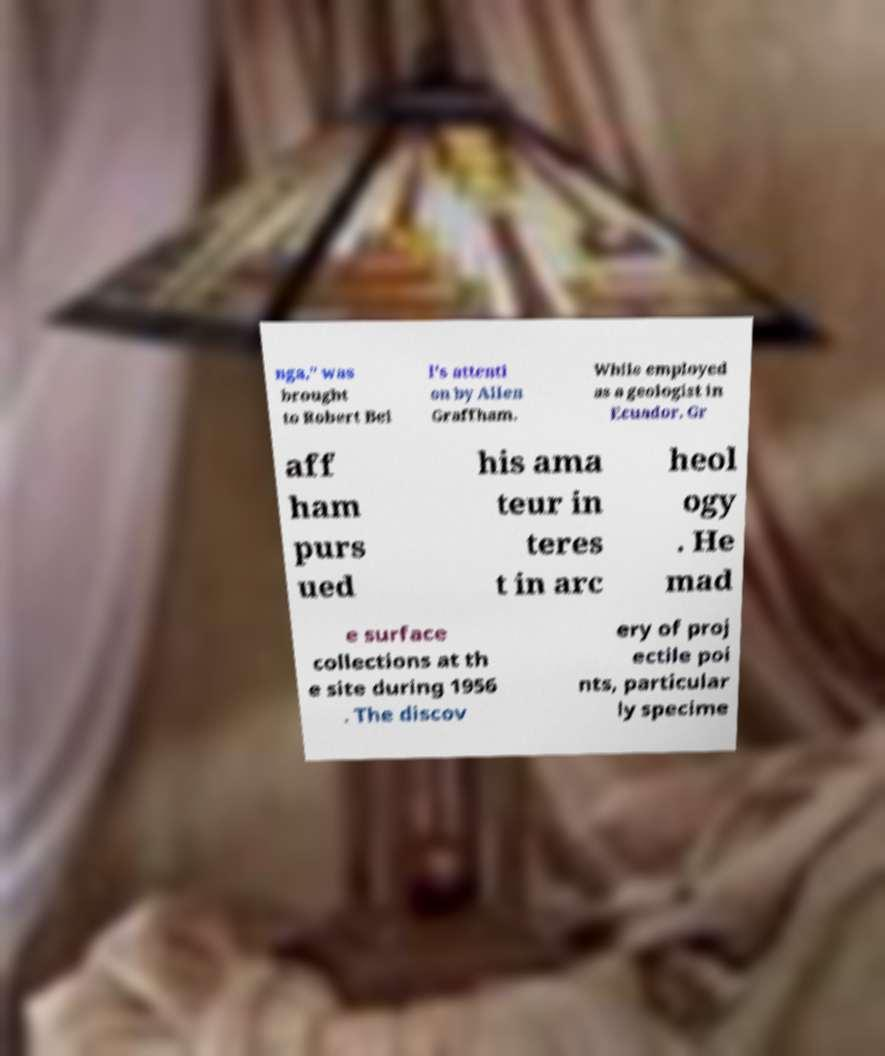Could you extract and type out the text from this image? nga," was brought to Robert Bel l's attenti on by Allen Graffham. While employed as a geologist in Ecuador, Gr aff ham purs ued his ama teur in teres t in arc heol ogy . He mad e surface collections at th e site during 1956 . The discov ery of proj ectile poi nts, particular ly specime 